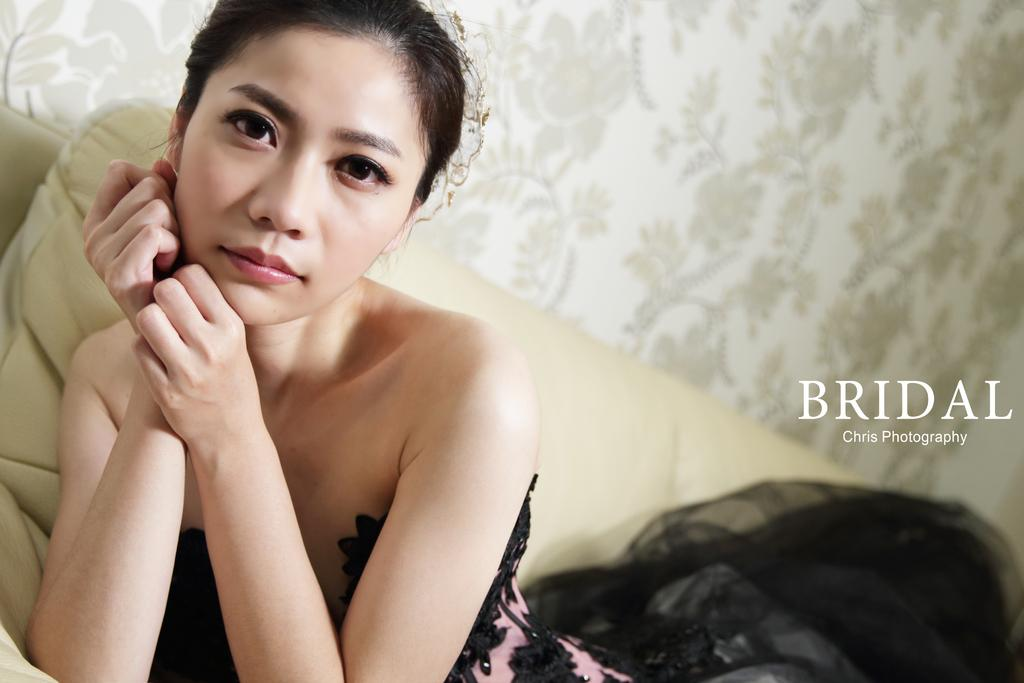Who is present in the image? There is a woman in the image. What is the woman wearing? The woman is wearing a dress. What is the woman doing in the image? The woman is sitting on a sofa. What can be seen in the background of the image? There is text visible in the background of the image. Can you see a crown on the woman's head in the image? No, there is no crown visible on the woman's head in the image. 